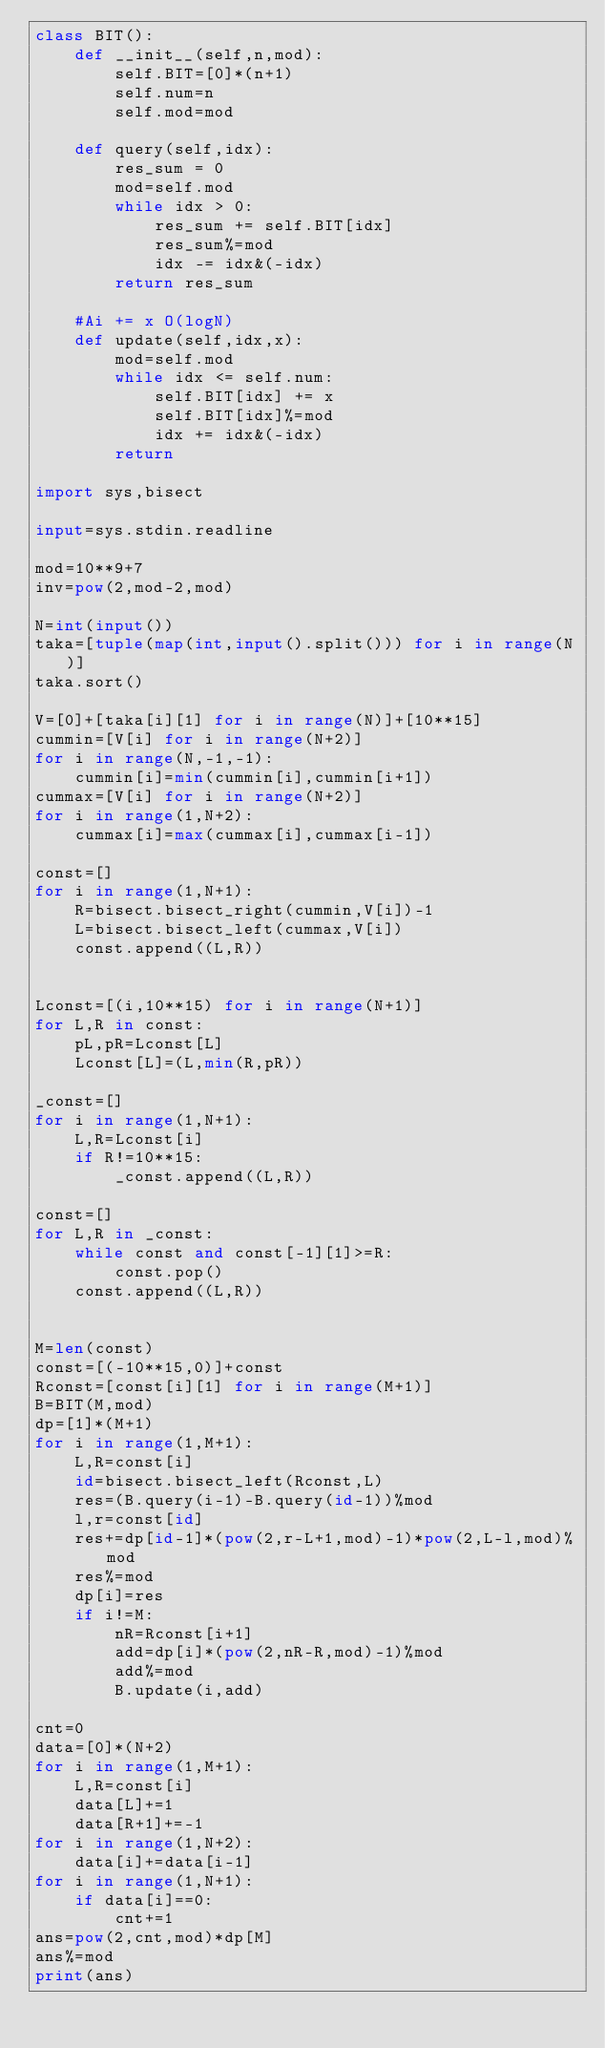Convert code to text. <code><loc_0><loc_0><loc_500><loc_500><_Python_>class BIT():
    def __init__(self,n,mod):
        self.BIT=[0]*(n+1)
        self.num=n
        self.mod=mod

    def query(self,idx):
        res_sum = 0
        mod=self.mod
        while idx > 0:
            res_sum += self.BIT[idx]
            res_sum%=mod
            idx -= idx&(-idx)
        return res_sum

    #Ai += x O(logN)
    def update(self,idx,x):
        mod=self.mod
        while idx <= self.num:
            self.BIT[idx] += x
            self.BIT[idx]%=mod
            idx += idx&(-idx)
        return

import sys,bisect

input=sys.stdin.readline

mod=10**9+7
inv=pow(2,mod-2,mod)

N=int(input())
taka=[tuple(map(int,input().split())) for i in range(N)]
taka.sort()

V=[0]+[taka[i][1] for i in range(N)]+[10**15]
cummin=[V[i] for i in range(N+2)]
for i in range(N,-1,-1):
    cummin[i]=min(cummin[i],cummin[i+1])
cummax=[V[i] for i in range(N+2)]
for i in range(1,N+2):
    cummax[i]=max(cummax[i],cummax[i-1])

const=[]
for i in range(1,N+1):
    R=bisect.bisect_right(cummin,V[i])-1
    L=bisect.bisect_left(cummax,V[i])
    const.append((L,R))


Lconst=[(i,10**15) for i in range(N+1)]
for L,R in const:
    pL,pR=Lconst[L]
    Lconst[L]=(L,min(R,pR))

_const=[]
for i in range(1,N+1):
    L,R=Lconst[i]
    if R!=10**15:
        _const.append((L,R))

const=[]
for L,R in _const:
    while const and const[-1][1]>=R:
        const.pop()
    const.append((L,R))


M=len(const)
const=[(-10**15,0)]+const
Rconst=[const[i][1] for i in range(M+1)]
B=BIT(M,mod)
dp=[1]*(M+1)
for i in range(1,M+1):
    L,R=const[i]
    id=bisect.bisect_left(Rconst,L)
    res=(B.query(i-1)-B.query(id-1))%mod
    l,r=const[id]
    res+=dp[id-1]*(pow(2,r-L+1,mod)-1)*pow(2,L-l,mod)%mod
    res%=mod
    dp[i]=res
    if i!=M:
        nR=Rconst[i+1]
        add=dp[i]*(pow(2,nR-R,mod)-1)%mod
        add%=mod
        B.update(i,add)

cnt=0
data=[0]*(N+2)
for i in range(1,M+1):
    L,R=const[i]
    data[L]+=1
    data[R+1]+=-1
for i in range(1,N+2):
    data[i]+=data[i-1]
for i in range(1,N+1):
    if data[i]==0:
        cnt+=1
ans=pow(2,cnt,mod)*dp[M]
ans%=mod
print(ans)
</code> 